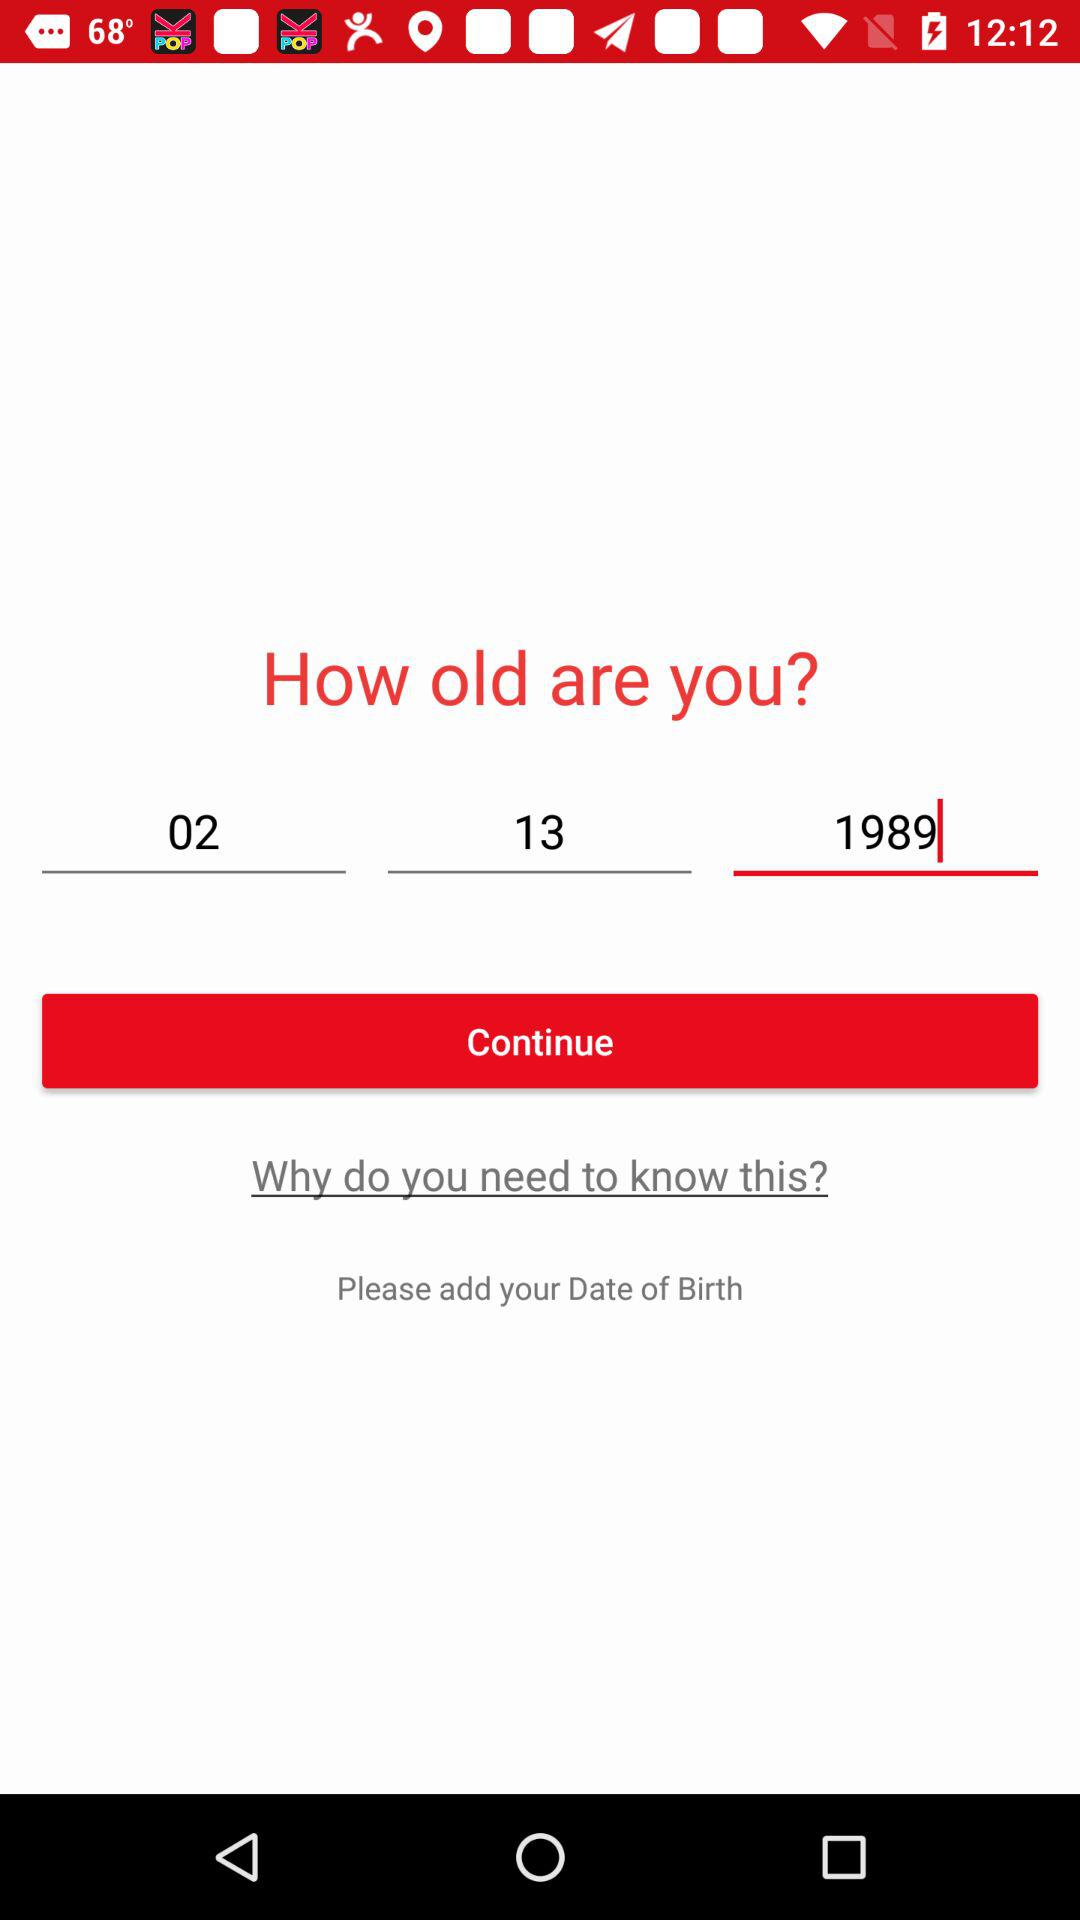What is the selected date? The selected date is February 13, 1989. 